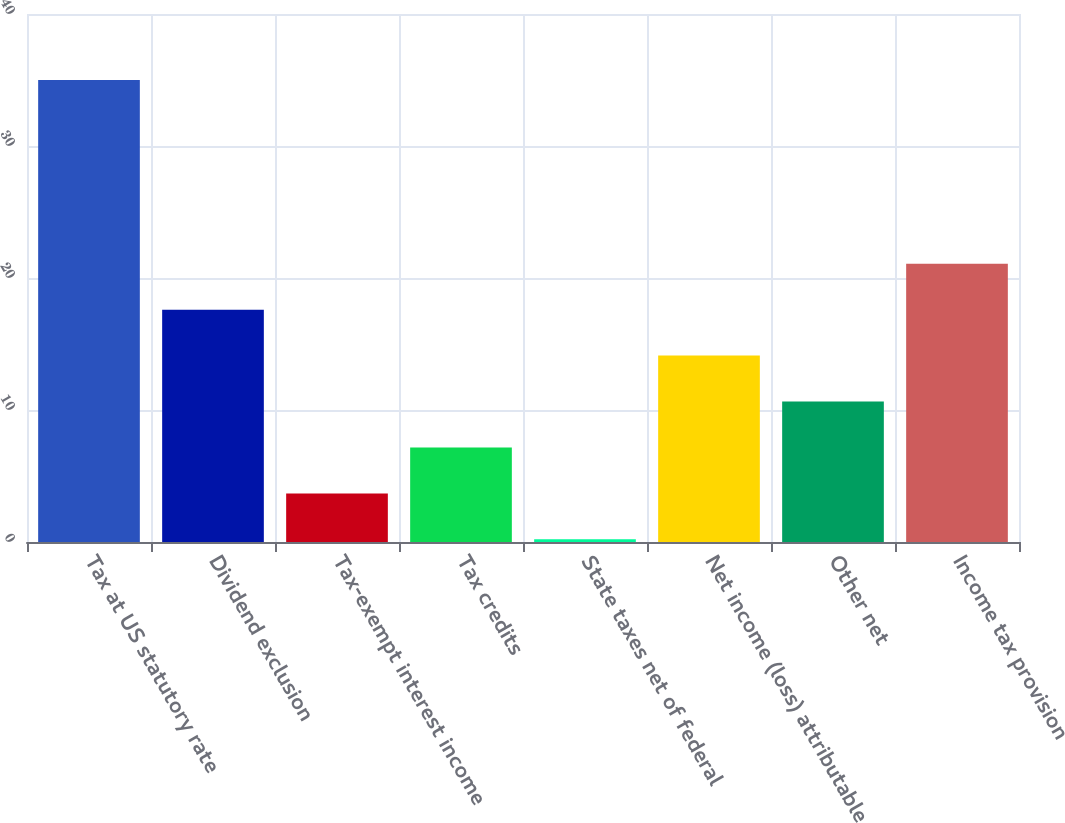Convert chart to OTSL. <chart><loc_0><loc_0><loc_500><loc_500><bar_chart><fcel>Tax at US statutory rate<fcel>Dividend exclusion<fcel>Tax-exempt interest income<fcel>Tax credits<fcel>State taxes net of federal<fcel>Net income (loss) attributable<fcel>Other net<fcel>Income tax provision<nl><fcel>35<fcel>17.6<fcel>3.68<fcel>7.16<fcel>0.2<fcel>14.12<fcel>10.64<fcel>21.08<nl></chart> 